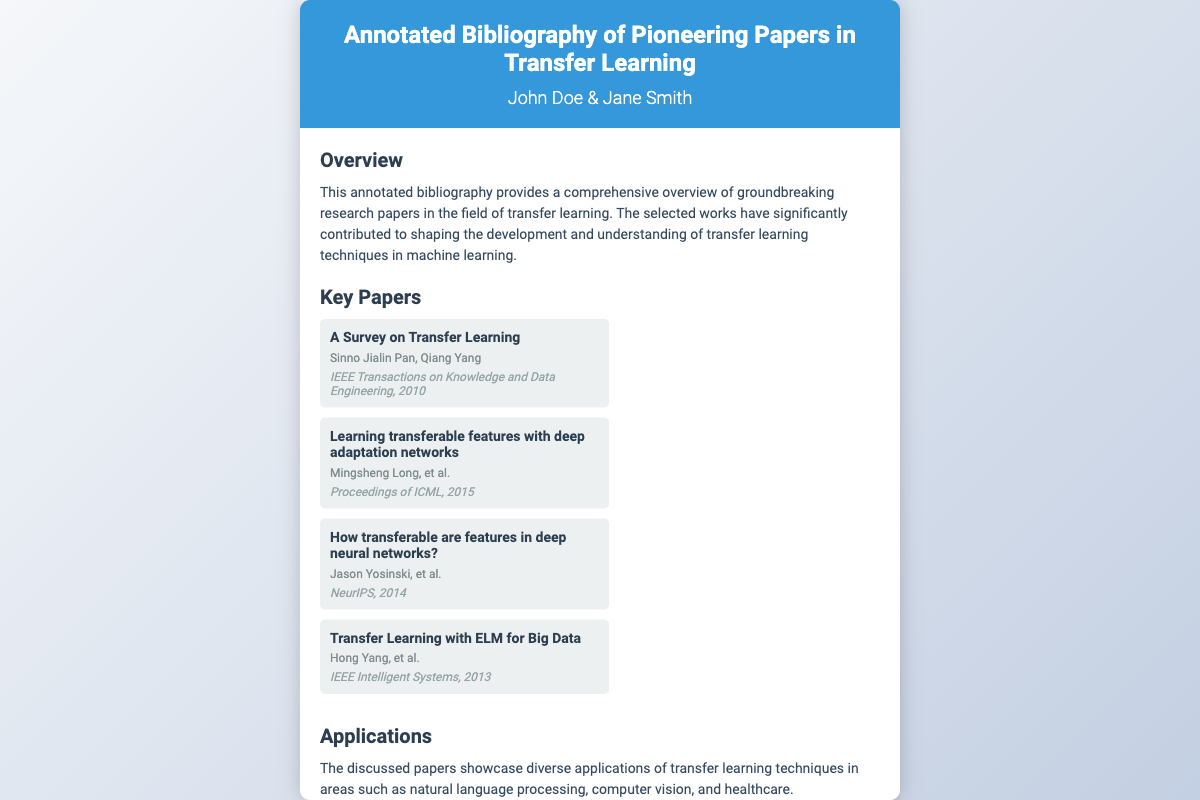what is the title of the book? The title of the book is prominently displayed in the header section of the cover.
Answer: Annotated Bibliography of Pioneering Papers in Transfer Learning who are the authors of the book? The authors' names are listed right below the title in the header section.
Answer: John Doe & Jane Smith what year was the book published? The publication year is included in the footer of the cover.
Answer: 2023 how many key papers are listed in the document? The document includes a section that specifically lists key papers in transfer learning.
Answer: Four what is one application area mentioned for transfer learning techniques? The application areas are detailed in the section about Applications in the document.
Answer: Natural language processing which paper is published in 2010? The years of publication for each key paper are provided under their respective titles.
Answer: A Survey on Transfer Learning who are the authors of "Learning transferable features with deep adaptation networks"? The authorship is detailed in the key papers section under the specific title.
Answer: Mingsheng Long, et al what journal published "Transfer Learning with ELM for Big Data"? Each paper is associated with a journal in the key papers section.
Answer: IEEE Intelligent Systems what is the color of the header section? The header section's background color is specified in the document design.
Answer: Blue 